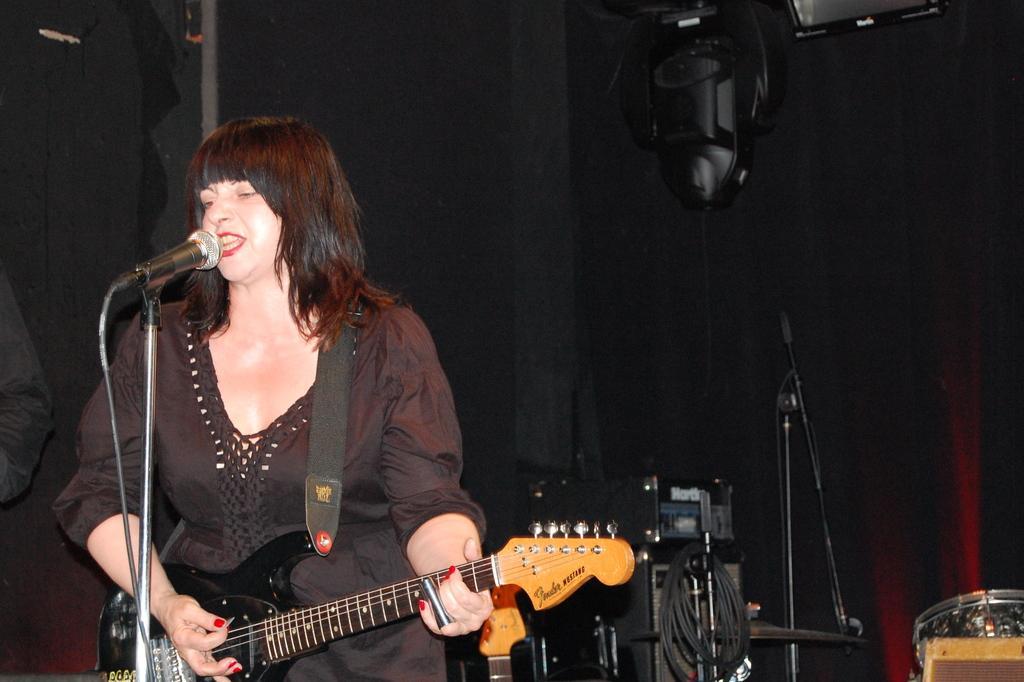Can you describe this image briefly? In this image I see a woman who is holding a guitar and standing in front of a mic. In the background I see few equipment. 